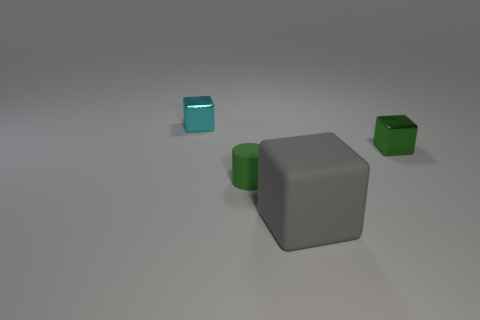What color is the cube that is the same material as the green cylinder? The cube sharing the same material as the green cylinder appears to be gray in color, exhibiting a matte finish that is distinct from the glossy surface of the other cube present. 